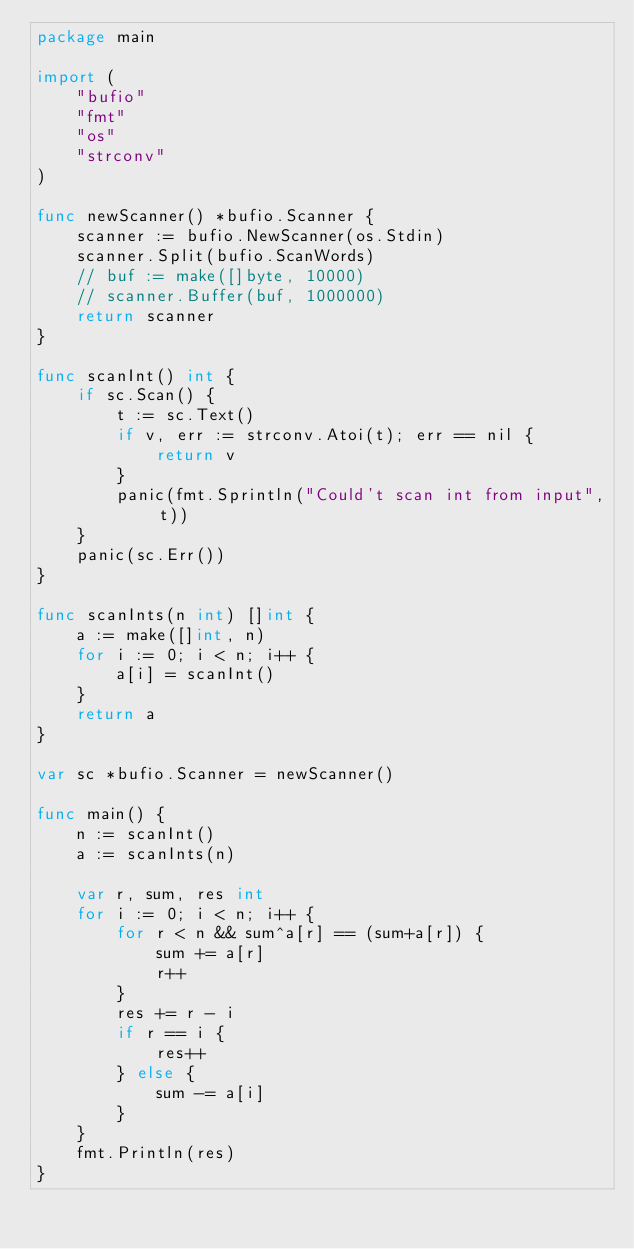<code> <loc_0><loc_0><loc_500><loc_500><_Go_>package main

import (
	"bufio"
	"fmt"
	"os"
	"strconv"
)

func newScanner() *bufio.Scanner {
	scanner := bufio.NewScanner(os.Stdin)
	scanner.Split(bufio.ScanWords)
	// buf := make([]byte, 10000)
	// scanner.Buffer(buf, 1000000)
	return scanner
}

func scanInt() int {
	if sc.Scan() {
		t := sc.Text()
		if v, err := strconv.Atoi(t); err == nil {
			return v
		}
		panic(fmt.Sprintln("Could't scan int from input", t))
	}
	panic(sc.Err())
}

func scanInts(n int) []int {
	a := make([]int, n)
	for i := 0; i < n; i++ {
		a[i] = scanInt()
	}
	return a
}

var sc *bufio.Scanner = newScanner()

func main() {
	n := scanInt()
	a := scanInts(n)

	var r, sum, res int
	for i := 0; i < n; i++ {
		for r < n && sum^a[r] == (sum+a[r]) {
			sum += a[r]
			r++
		}
		res += r - i
		if r == i {
			res++
		} else {
			sum -= a[i]
		}
	}
	fmt.Println(res)
}
</code> 